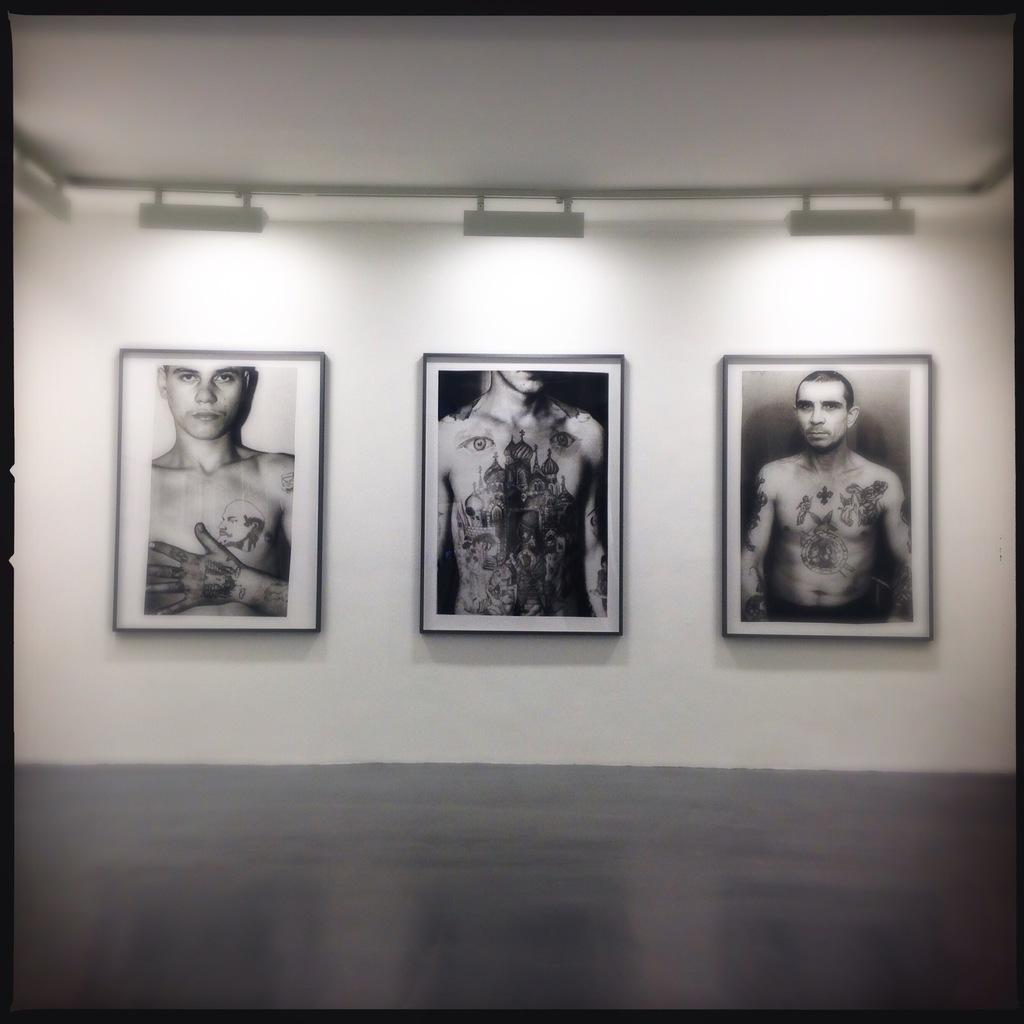What is the color scheme of the image? The image is black and white. What can be seen on the wall in the image? There are photo frames with pictures of people on a wall. What architectural feature is visible in the image? There is a roof visible in the image. What is present on the roof? There are lights on the roof. What type of drug can be seen being pushed downtown in the image? There is no drug or downtown location present in the image. The image is black and white and features photo frames with pictures of people on a wall, a roof, and lights on the roof. 